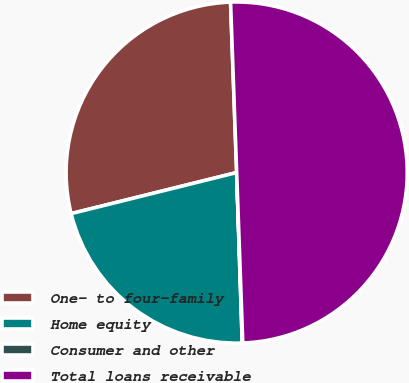Convert chart to OTSL. <chart><loc_0><loc_0><loc_500><loc_500><pie_chart><fcel>One- to four-family<fcel>Home equity<fcel>Consumer and other<fcel>Total loans receivable<nl><fcel>28.3%<fcel>21.65%<fcel>0.05%<fcel>50.0%<nl></chart> 